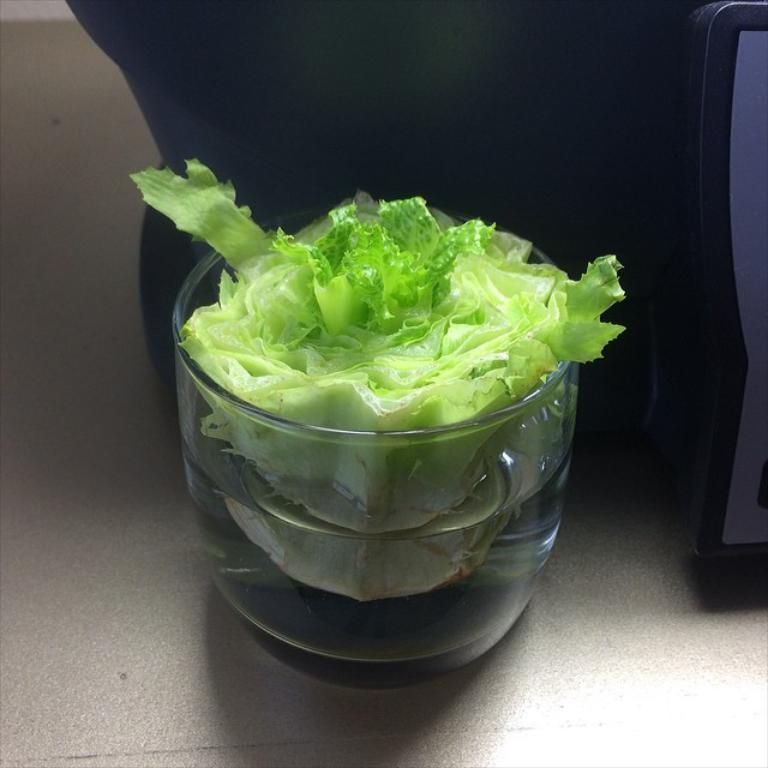What type of food is in the bowl in the image? There is a salad in a bowl in the image. What type of attention does the zinc in the image require? There is no zinc present in the image, so it does not require any attention. 